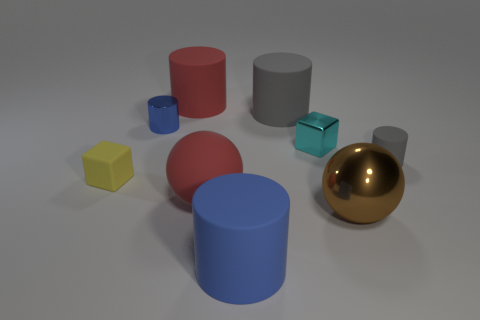Subtract 2 cylinders. How many cylinders are left? 3 Subtract all yellow cylinders. Subtract all yellow blocks. How many cylinders are left? 5 Add 1 large red matte balls. How many objects exist? 10 Subtract all balls. How many objects are left? 7 Subtract all big green cubes. Subtract all blue shiny cylinders. How many objects are left? 8 Add 1 metal cylinders. How many metal cylinders are left? 2 Add 4 yellow things. How many yellow things exist? 5 Subtract 0 gray spheres. How many objects are left? 9 